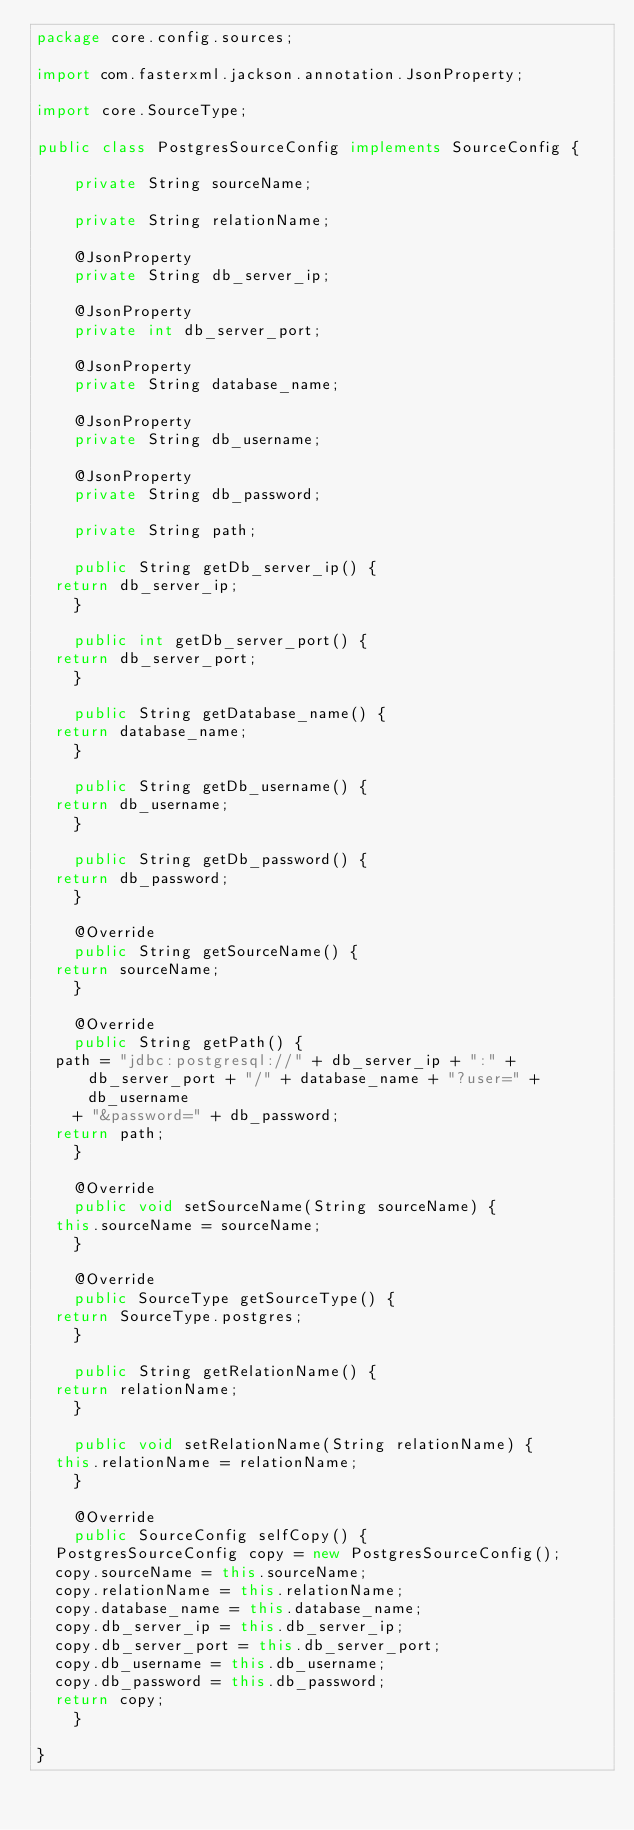<code> <loc_0><loc_0><loc_500><loc_500><_Java_>package core.config.sources;

import com.fasterxml.jackson.annotation.JsonProperty;

import core.SourceType;

public class PostgresSourceConfig implements SourceConfig {

    private String sourceName;

    private String relationName;

    @JsonProperty
    private String db_server_ip;

    @JsonProperty
    private int db_server_port;

    @JsonProperty
    private String database_name;

    @JsonProperty
    private String db_username;

    @JsonProperty
    private String db_password;

    private String path;

    public String getDb_server_ip() {
	return db_server_ip;
    }

    public int getDb_server_port() {
	return db_server_port;
    }

    public String getDatabase_name() {
	return database_name;
    }

    public String getDb_username() {
	return db_username;
    }

    public String getDb_password() {
	return db_password;
    }

    @Override
    public String getSourceName() {
	return sourceName;
    }

    @Override
    public String getPath() {
	path = "jdbc:postgresql://" + db_server_ip + ":" + db_server_port + "/" + database_name + "?user=" + db_username
		+ "&password=" + db_password;
	return path;
    }

    @Override
    public void setSourceName(String sourceName) {
	this.sourceName = sourceName;
    }

    @Override
    public SourceType getSourceType() {
	return SourceType.postgres;
    }

    public String getRelationName() {
	return relationName;
    }

    public void setRelationName(String relationName) {
	this.relationName = relationName;
    }

    @Override
    public SourceConfig selfCopy() {
	PostgresSourceConfig copy = new PostgresSourceConfig();
	copy.sourceName = this.sourceName;
	copy.relationName = this.relationName;
	copy.database_name = this.database_name;
	copy.db_server_ip = this.db_server_ip;
	copy.db_server_port = this.db_server_port;
	copy.db_username = this.db_username;
	copy.db_password = this.db_password;
	return copy;
    }

}
</code> 